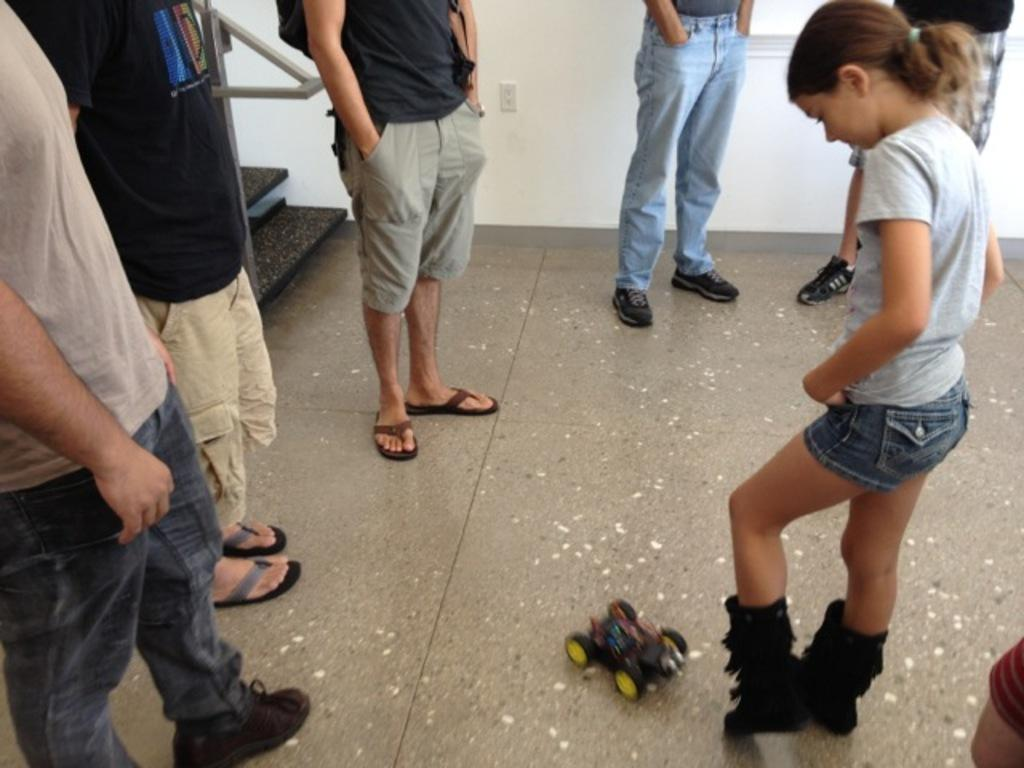How many people are in the image? There is a group of people standing in the image. What is on the floor in the image? There is a toy on the floor in the image. What architectural feature is visible at the back of the image? There is a staircase at the back of the image. What is associated with the staircase? There is a handrail associated with the staircase. What can be seen in the image that provides natural light? There appears to be a window in the image. What type of boot is being worn by the person in the image? There is no mention of boots or footwear in the image; the focus is on the group of people, the toy, the staircase, the handrail, and the window. 